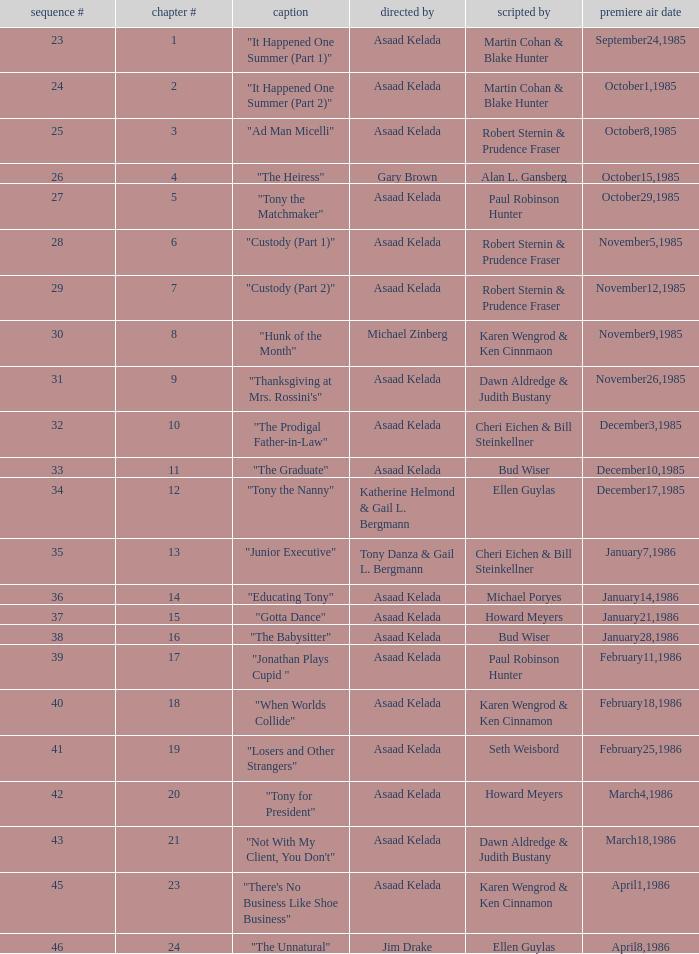What season features writer Michael Poryes? 14.0. 